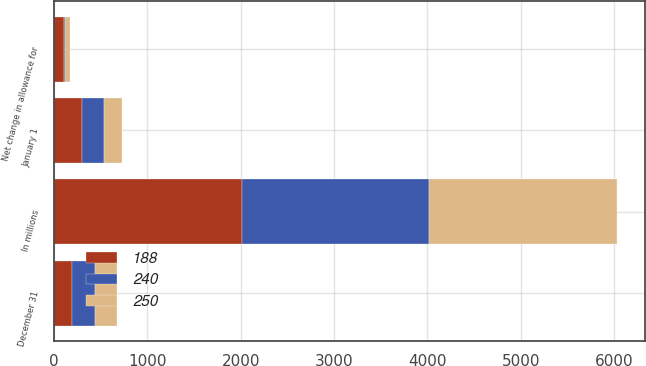<chart> <loc_0><loc_0><loc_500><loc_500><stacked_bar_chart><ecel><fcel>In millions<fcel>January 1<fcel>Net change in allowance for<fcel>December 31<nl><fcel>240<fcel>2012<fcel>240<fcel>10<fcel>250<nl><fcel>250<fcel>2011<fcel>188<fcel>52<fcel>240<nl><fcel>188<fcel>2010<fcel>296<fcel>108<fcel>188<nl></chart> 